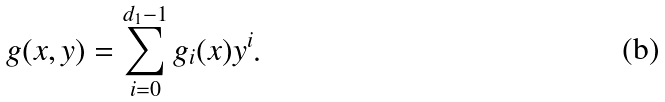Convert formula to latex. <formula><loc_0><loc_0><loc_500><loc_500>g ( x , y ) = \sum _ { i = 0 } ^ { d _ { 1 } - 1 } g _ { i } ( x ) y ^ { i } .</formula> 